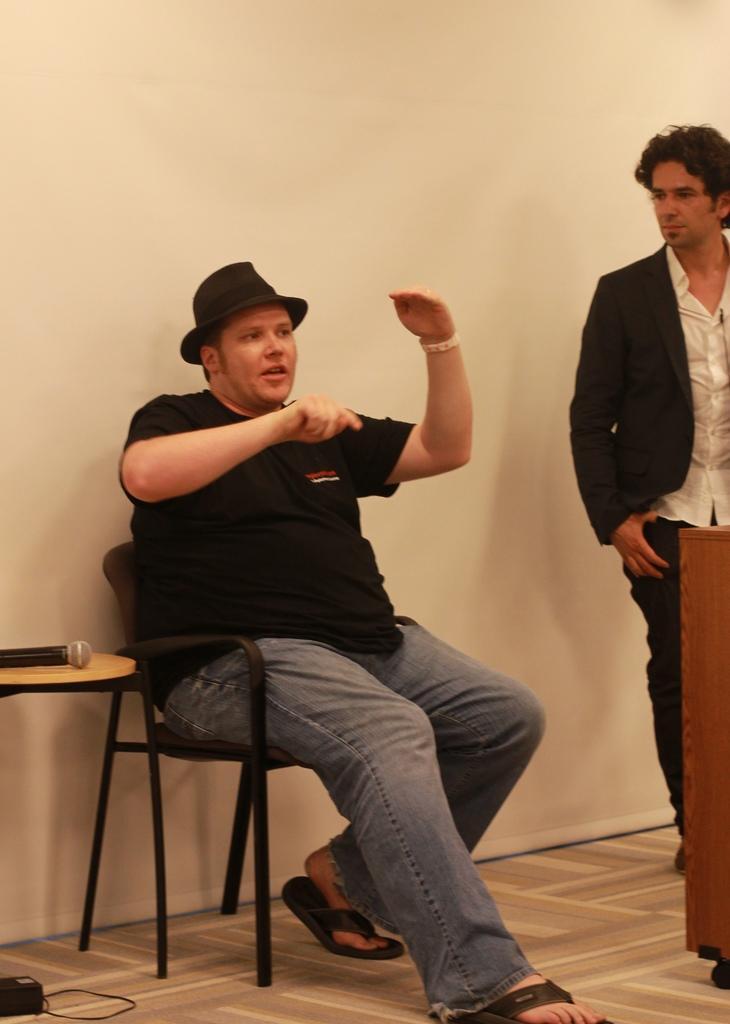Could you give a brief overview of what you see in this image? In this image I can see two persons. The person at right wearing black blazer, white shirt and black color pant, the person at left wearing black color shirt and gray color pant. I can also see a microphone on the table, background the wall is in cream color. 